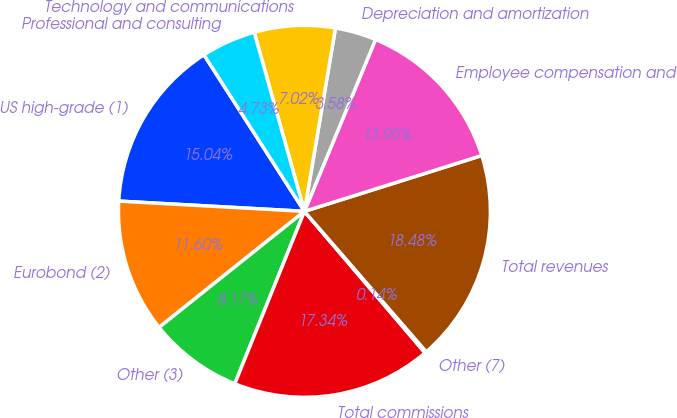<chart> <loc_0><loc_0><loc_500><loc_500><pie_chart><fcel>US high-grade (1)<fcel>Eurobond (2)<fcel>Other (3)<fcel>Total commissions<fcel>Other (7)<fcel>Total revenues<fcel>Employee compensation and<fcel>Depreciation and amortization<fcel>Technology and communications<fcel>Professional and consulting<nl><fcel>15.04%<fcel>11.6%<fcel>8.17%<fcel>17.34%<fcel>0.14%<fcel>18.48%<fcel>13.9%<fcel>3.58%<fcel>7.02%<fcel>4.73%<nl></chart> 